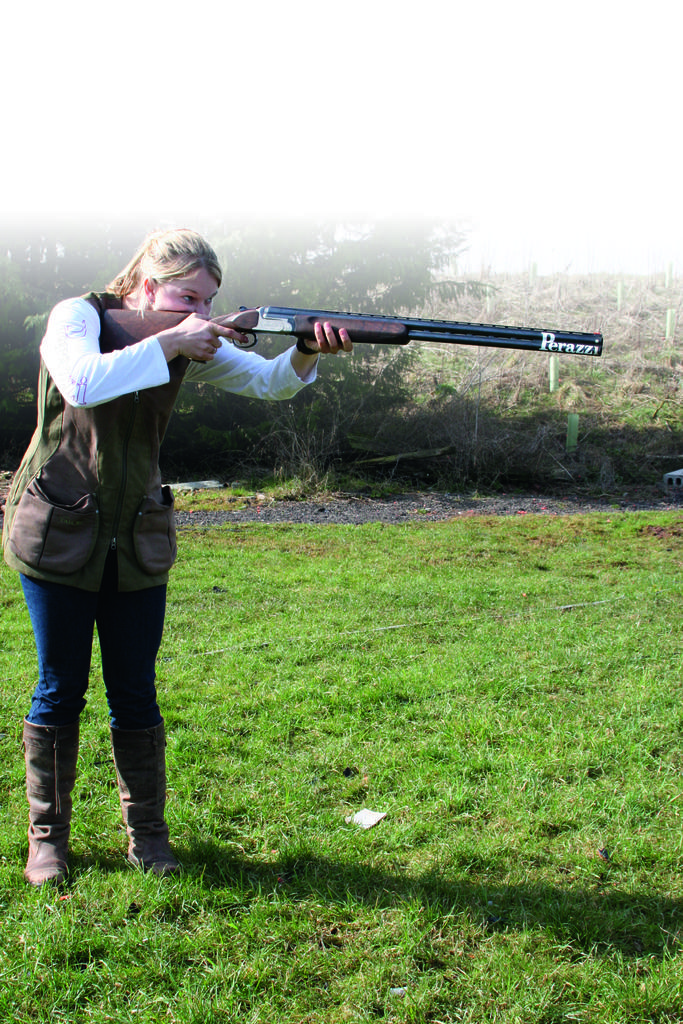Who is the main subject in the image? There is a woman in the center of the image. What is the woman doing in the image? The woman is standing and holding a gun. What type of terrain is visible in the image? There is grass on the ground. What can be seen in the background of the image? There are trees in the background of the image. What type of bird is flying over the woman in the image? There is no bird visible in the image. Is the woman delivering a parcel in the image? There is no parcel present in the image, and the woman is holding a gun, not a parcel. 